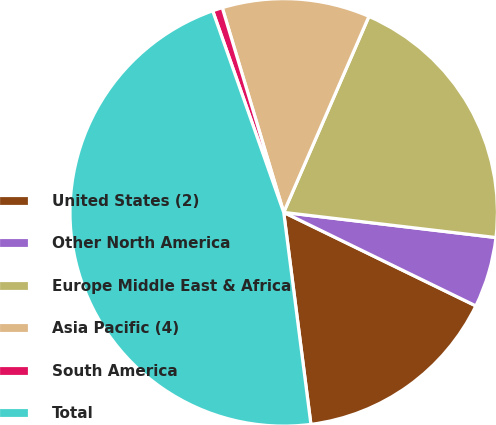<chart> <loc_0><loc_0><loc_500><loc_500><pie_chart><fcel>United States (2)<fcel>Other North America<fcel>Europe Middle East & Africa<fcel>Asia Pacific (4)<fcel>South America<fcel>Total<nl><fcel>15.76%<fcel>5.33%<fcel>20.35%<fcel>11.17%<fcel>0.75%<fcel>46.64%<nl></chart> 